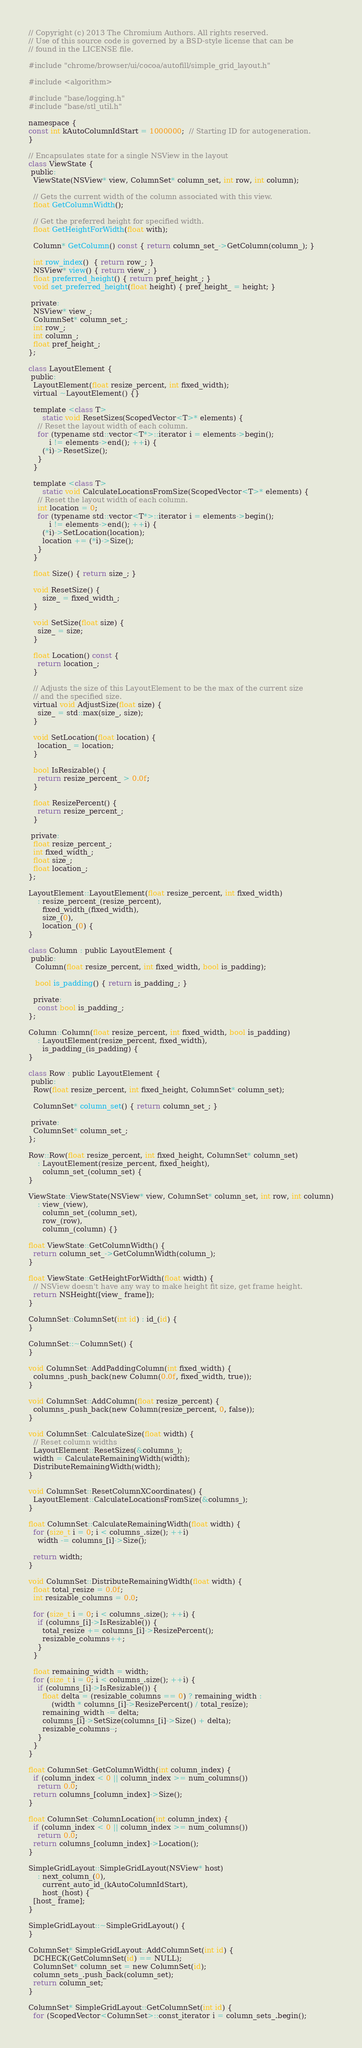Convert code to text. <code><loc_0><loc_0><loc_500><loc_500><_ObjectiveC_>// Copyright (c) 2013 The Chromium Authors. All rights reserved.
// Use of this source code is governed by a BSD-style license that can be
// found in the LICENSE file.

#include "chrome/browser/ui/cocoa/autofill/simple_grid_layout.h"

#include <algorithm>

#include "base/logging.h"
#include "base/stl_util.h"

namespace {
const int kAutoColumnIdStart = 1000000;  // Starting ID for autogeneration.
}

// Encapsulates state for a single NSView in the layout
class ViewState {
 public:
  ViewState(NSView* view, ColumnSet* column_set, int row, int column);

  // Gets the current width of the column associated with this view.
  float GetColumnWidth();

  // Get the preferred height for specified width.
  float GetHeightForWidth(float with);

  Column* GetColumn() const { return column_set_->GetColumn(column_); }

  int row_index()  { return row_; }
  NSView* view() { return view_; }
  float preferred_height() { return pref_height_; }
  void set_preferred_height(float height) { pref_height_ = height; }

 private:
  NSView* view_;
  ColumnSet* column_set_;
  int row_;
  int column_;
  float pref_height_;
};

class LayoutElement {
 public:
  LayoutElement(float resize_percent, int fixed_width);
  virtual ~LayoutElement() {}

  template <class T>
      static void ResetSizes(ScopedVector<T>* elements) {
    // Reset the layout width of each column.
    for (typename std::vector<T*>::iterator i = elements->begin();
         i != elements->end(); ++i) {
      (*i)->ResetSize();
    }
  }

  template <class T>
      static void CalculateLocationsFromSize(ScopedVector<T>* elements) {
    // Reset the layout width of each column.
    int location = 0;
    for (typename std::vector<T*>::iterator i = elements->begin();
         i != elements->end(); ++i) {
      (*i)->SetLocation(location);
      location += (*i)->Size();
    }
  }

  float Size() { return size_; }

  void ResetSize() {
      size_ = fixed_width_;
  }

  void SetSize(float size) {
    size_ = size;
  }

  float Location() const {
    return location_;
  }

  // Adjusts the size of this LayoutElement to be the max of the current size
  // and the specified size.
  virtual void AdjustSize(float size) {
    size_ = std::max(size_, size);
  }

  void SetLocation(float location) {
    location_ = location;
  }

  bool IsResizable() {
    return resize_percent_ > 0.0f;
  }

  float ResizePercent() {
    return resize_percent_;
  }

 private:
  float resize_percent_;
  int fixed_width_;
  float size_;
  float location_;
};

LayoutElement::LayoutElement(float resize_percent, int fixed_width)
    : resize_percent_(resize_percent),
      fixed_width_(fixed_width),
      size_(0),
      location_(0) {
}

class Column : public LayoutElement {
 public:
   Column(float resize_percent, int fixed_width, bool is_padding);

   bool is_padding() { return is_padding_; }

  private:
    const bool is_padding_;
};

Column::Column(float resize_percent, int fixed_width, bool is_padding)
    : LayoutElement(resize_percent, fixed_width),
      is_padding_(is_padding) {
}

class Row : public LayoutElement {
 public:
  Row(float resize_percent, int fixed_height, ColumnSet* column_set);

  ColumnSet* column_set() { return column_set_; }

 private:
  ColumnSet* column_set_;
};

Row::Row(float resize_percent, int fixed_height, ColumnSet* column_set)
    : LayoutElement(resize_percent, fixed_height),
      column_set_(column_set) {
}

ViewState::ViewState(NSView* view, ColumnSet* column_set, int row, int column)
    : view_(view),
      column_set_(column_set),
      row_(row),
      column_(column) {}

float ViewState::GetColumnWidth() {
  return column_set_->GetColumnWidth(column_);
}

float ViewState::GetHeightForWidth(float width) {
  // NSView doesn't have any way to make height fit size, get frame height.
  return NSHeight([view_ frame]);
}

ColumnSet::ColumnSet(int id) : id_(id) {
}

ColumnSet::~ColumnSet() {
}

void ColumnSet::AddPaddingColumn(int fixed_width) {
  columns_.push_back(new Column(0.0f, fixed_width, true));
}

void ColumnSet::AddColumn(float resize_percent) {
  columns_.push_back(new Column(resize_percent, 0, false));
}

void ColumnSet::CalculateSize(float width) {
  // Reset column widths
  LayoutElement::ResetSizes(&columns_);
  width = CalculateRemainingWidth(width);
  DistributeRemainingWidth(width);
}

void ColumnSet::ResetColumnXCoordinates() {
  LayoutElement::CalculateLocationsFromSize(&columns_);
}

float ColumnSet::CalculateRemainingWidth(float width) {
  for (size_t i = 0; i < columns_.size(); ++i)
    width -= columns_[i]->Size();

  return width;
}

void ColumnSet::DistributeRemainingWidth(float width) {
  float total_resize = 0.0f;
  int resizable_columns = 0.0;

  for (size_t i = 0; i < columns_.size(); ++i) {
    if (columns_[i]->IsResizable()) {
      total_resize += columns_[i]->ResizePercent();
      resizable_columns++;
    }
  }

  float remaining_width = width;
  for (size_t i = 0; i < columns_.size(); ++i) {
    if (columns_[i]->IsResizable()) {
      float delta = (resizable_columns == 0) ? remaining_width :
          (width * columns_[i]->ResizePercent() / total_resize);
      remaining_width -= delta;
      columns_[i]->SetSize(columns_[i]->Size() + delta);
      resizable_columns--;
    }
  }
}

float ColumnSet::GetColumnWidth(int column_index) {
  if (column_index < 0 || column_index >= num_columns())
    return 0.0;
  return columns_[column_index]->Size();
}

float ColumnSet::ColumnLocation(int column_index) {
  if (column_index < 0 || column_index >= num_columns())
    return 0.0;
  return columns_[column_index]->Location();
}

SimpleGridLayout::SimpleGridLayout(NSView* host)
    : next_column_(0),
      current_auto_id_(kAutoColumnIdStart),
      host_(host) {
  [host_ frame];
}

SimpleGridLayout::~SimpleGridLayout() {
}

ColumnSet* SimpleGridLayout::AddColumnSet(int id) {
  DCHECK(GetColumnSet(id) == NULL);
  ColumnSet* column_set = new ColumnSet(id);
  column_sets_.push_back(column_set);
  return column_set;
}

ColumnSet* SimpleGridLayout::GetColumnSet(int id) {
  for (ScopedVector<ColumnSet>::const_iterator i = column_sets_.begin();</code> 